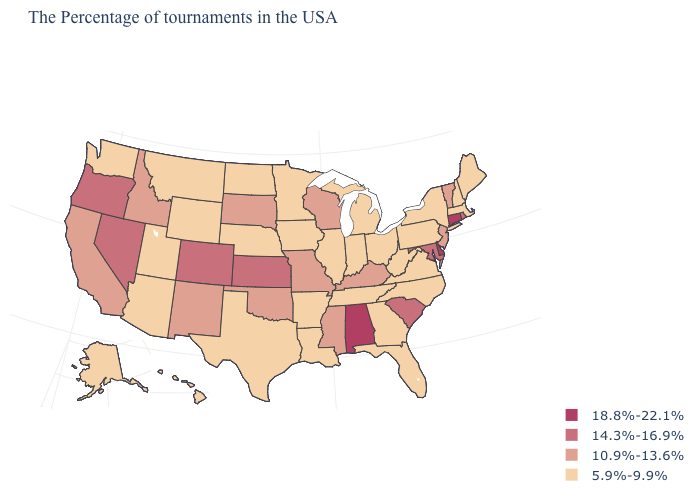How many symbols are there in the legend?
Keep it brief. 4. What is the value of Washington?
Short answer required. 5.9%-9.9%. What is the value of South Dakota?
Quick response, please. 10.9%-13.6%. Among the states that border Michigan , which have the highest value?
Short answer required. Wisconsin. Does Indiana have the highest value in the MidWest?
Write a very short answer. No. Name the states that have a value in the range 18.8%-22.1%?
Answer briefly. Connecticut, Delaware, Alabama. What is the value of Massachusetts?
Short answer required. 5.9%-9.9%. What is the value of Georgia?
Be succinct. 5.9%-9.9%. What is the value of Alabama?
Concise answer only. 18.8%-22.1%. Does Rhode Island have the lowest value in the Northeast?
Quick response, please. No. What is the lowest value in states that border Arizona?
Quick response, please. 5.9%-9.9%. What is the value of Missouri?
Quick response, please. 10.9%-13.6%. Name the states that have a value in the range 10.9%-13.6%?
Quick response, please. Vermont, New Jersey, Kentucky, Wisconsin, Mississippi, Missouri, Oklahoma, South Dakota, New Mexico, Idaho, California. Does Washington have a higher value than Massachusetts?
Give a very brief answer. No. Which states have the lowest value in the USA?
Give a very brief answer. Maine, Massachusetts, New Hampshire, New York, Pennsylvania, Virginia, North Carolina, West Virginia, Ohio, Florida, Georgia, Michigan, Indiana, Tennessee, Illinois, Louisiana, Arkansas, Minnesota, Iowa, Nebraska, Texas, North Dakota, Wyoming, Utah, Montana, Arizona, Washington, Alaska, Hawaii. 